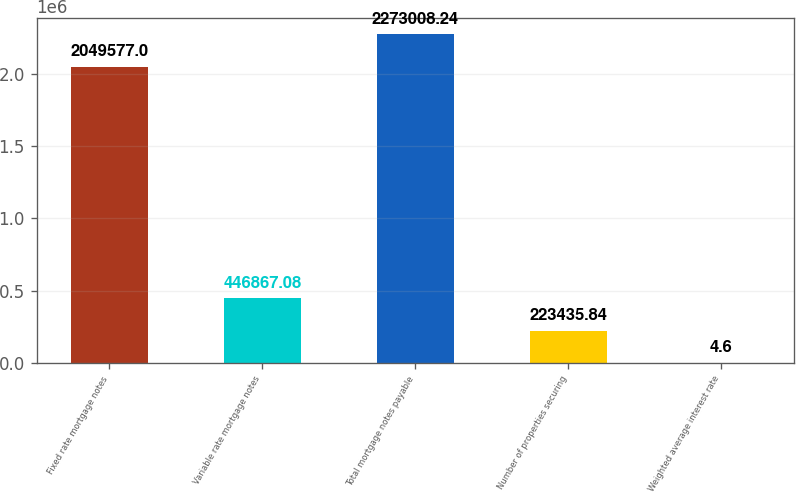Convert chart. <chart><loc_0><loc_0><loc_500><loc_500><bar_chart><fcel>Fixed rate mortgage notes<fcel>Variable rate mortgage notes<fcel>Total mortgage notes payable<fcel>Number of properties securing<fcel>Weighted average interest rate<nl><fcel>2.04958e+06<fcel>446867<fcel>2.27301e+06<fcel>223436<fcel>4.6<nl></chart> 